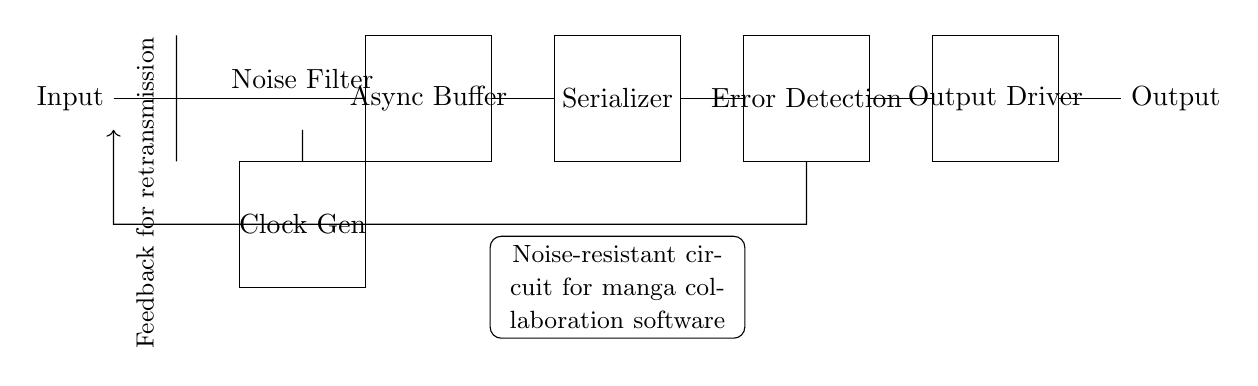What is the function of the Schmitt trigger in this circuit? The Schmitt trigger is used for noise reduction, providing clean transitions of the input signal by eliminating spurious voltage variations.
Answer: Noise Filter What component precedes the asynchronous data buffer? The component connected directly before the asynchronous data buffer is the Schmitt trigger, which outputs the noise-filtered signal to the buffer.
Answer: Schmitt trigger What does the feedback loop in this circuit indicate? The feedback loop indicates that there is a connection allowing the system to retransmit data, helping to ensure data integrity during transmission.
Answer: Feedback for retransmission How many main components are in this circuit? The main components present in the circuit include a noise filter, an async buffer, a clock generator, a serializer, an error detection circuit, and an output driver, totaling six components.
Answer: Six What is the role of the clock generator in this circuit? The clock generator provides timing signals required for synchronized data processing and ensures data is transmitted at correct intervals.
Answer: Clock Gen What type of circuit design is this diagram illustrating? The circuit is an asynchronous design, which means it does not use a shared clock signal for timing control between components, allowing independent operation.
Answer: Asynchronous 